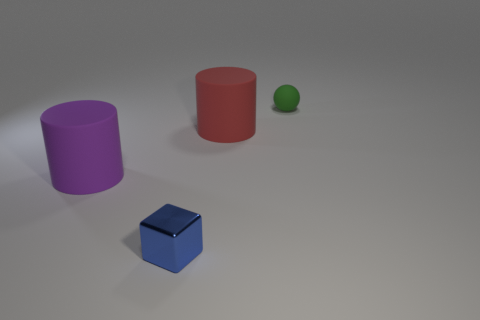What shape is the green thing that is the same size as the blue metal cube? The green object that matches the size of the blue cube is a sphere. It appears to be a small, simple three-dimensional shape with a continuous surface. 